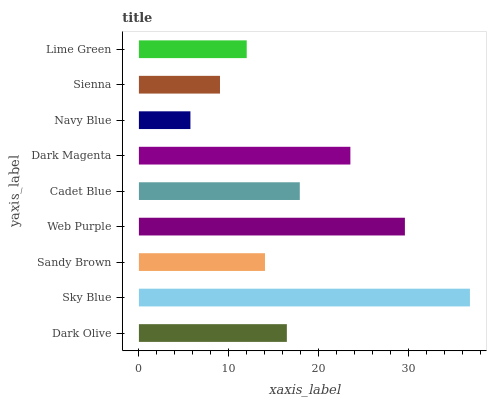Is Navy Blue the minimum?
Answer yes or no. Yes. Is Sky Blue the maximum?
Answer yes or no. Yes. Is Sandy Brown the minimum?
Answer yes or no. No. Is Sandy Brown the maximum?
Answer yes or no. No. Is Sky Blue greater than Sandy Brown?
Answer yes or no. Yes. Is Sandy Brown less than Sky Blue?
Answer yes or no. Yes. Is Sandy Brown greater than Sky Blue?
Answer yes or no. No. Is Sky Blue less than Sandy Brown?
Answer yes or no. No. Is Dark Olive the high median?
Answer yes or no. Yes. Is Dark Olive the low median?
Answer yes or no. Yes. Is Sienna the high median?
Answer yes or no. No. Is Web Purple the low median?
Answer yes or no. No. 